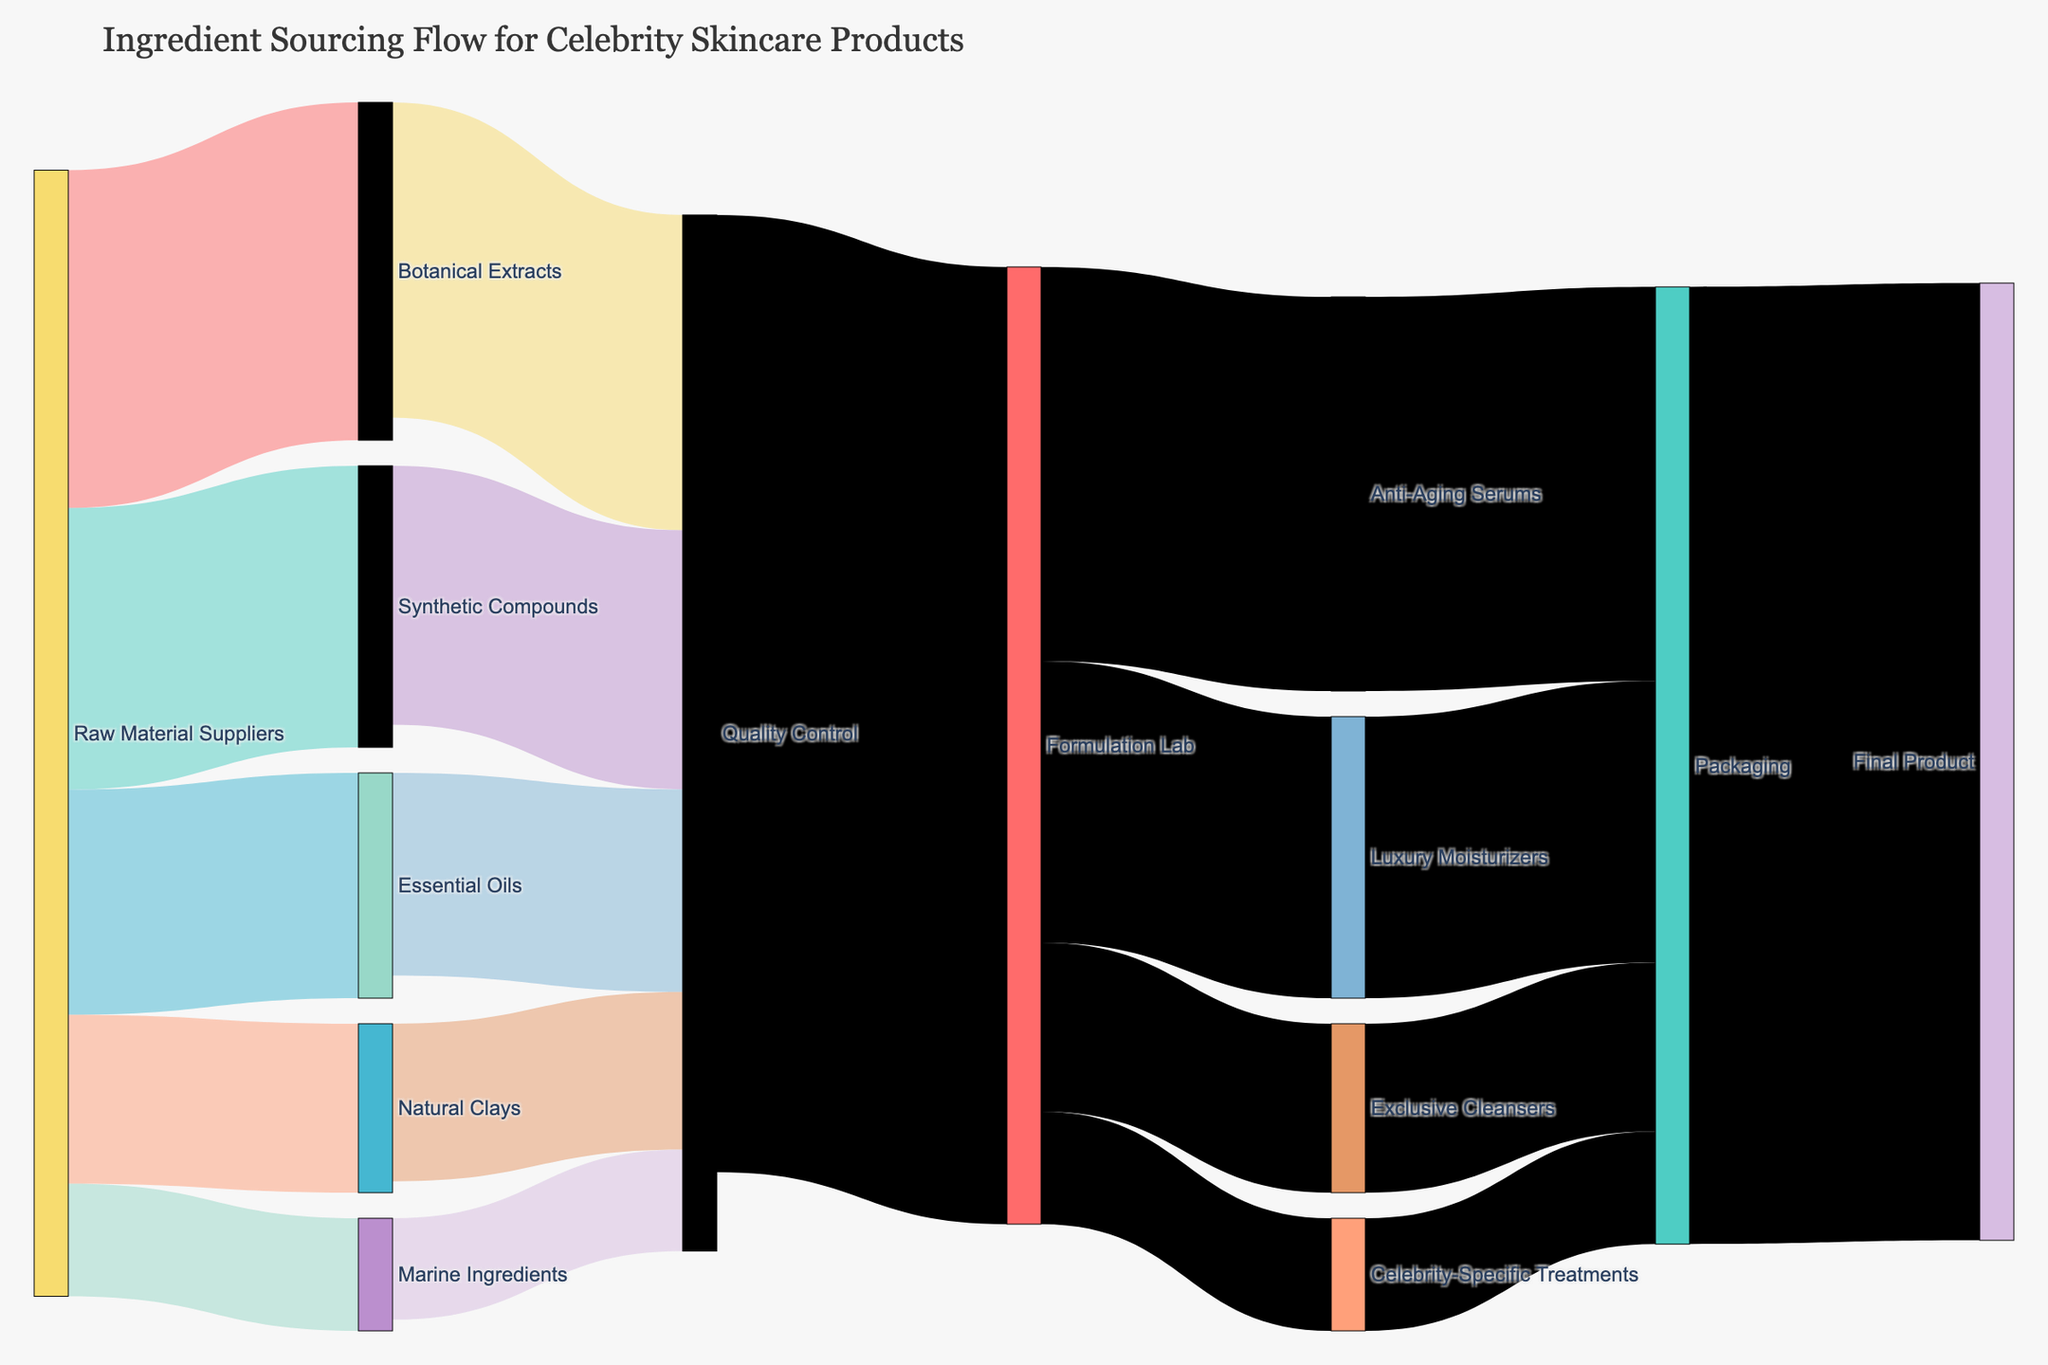What is the title of the figure? The title of the figure is typically located at the top center. It gives a brief description of what the figure represents. The title "Ingredient Sourcing Flow for Celebrity Skincare Products" clearly describes the purpose of the Sankey Diagram.
Answer: Ingredient Sourcing Flow for Celebrity Skincare Products How many raw material suppliers are there? One can count the sources directly connected to the "Raw Material Suppliers". There are 5 sources: Botanical Extracts, Synthetic Compounds, Essential Oils, Natural Clays, and Marine Ingredients.
Answer: 5 What proportion of raw materials go through Quality Control? The sum of values for all raw materials leading to Quality Control is (28+23+18+14+9)=92. The total raw materials from suppliers is (30+25+20+15+10)=100. So, the proportion is 92/100.
Answer: 92% Which product formulation receives the most input from the Formulation Lab? By comparing the values directed from "Formulation Lab" to each formulated product, Anti-Aging Serums receive the most input, which is 35.
Answer: Anti-Aging Serums What is the total value flowing from the Formulation Lab? Summing up all values coming from the Formulation Lab gives (35 + 25 + 15 + 10) which equals 85.
Answer: 85 What is the final product output value? The value of the Packaging flowing into the Final Product is 85, as indicated by the link between Packaging and Final Product.
Answer: 85 Which raw material has the smallest value flowing into Quality Control? By comparing the values of the raw materials leading to Quality Control, Marine Ingredients has the smallest value, which is 9.
Answer: Marine Ingredients If one unit of Marine Ingredients fails Quality Control, what percentage of its initial value is lost? Marine Ingredients going to Quality Control is 10. If 1 unit fails, the loss would be (1/10)*100.
Answer: 10% How does the value from Quality Control to Formulation Lab compare with the sum total of inputs from raw material suppliers? The total inputs from raw material suppliers is 100, and the value from Quality Control to Formulation Lab is 85. Comparing these, the output to Formulation Lab is 85/100= 85%.
Answer: 85% What is the relationship between the amount of Anti-Aging Serums and Luxury Moisturizers directed toward Packaging? Anti-Aging Serums direct 35 to Packaging, while Luxury Moisturizers direct 25. Thus, Anti-Aging Serums have a higher value directed toward Packaging.
Answer: Anti-Aging Serums > Luxury Moisturizers 